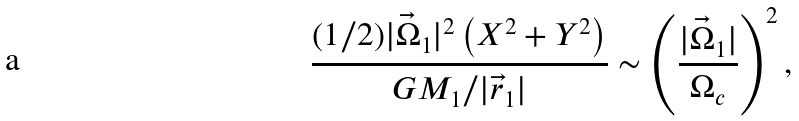Convert formula to latex. <formula><loc_0><loc_0><loc_500><loc_500>\frac { { ( 1 / 2 ) | \vec { \Omega } _ { 1 } | ^ { 2 } \left ( X ^ { 2 } + Y ^ { 2 } \right ) } } { { G M _ { 1 } / | \vec { r } _ { 1 } | } } \sim \left ( \frac { { | \vec { \Omega } _ { 1 } | } } { \Omega _ { c } } \right ) ^ { 2 } ,</formula> 